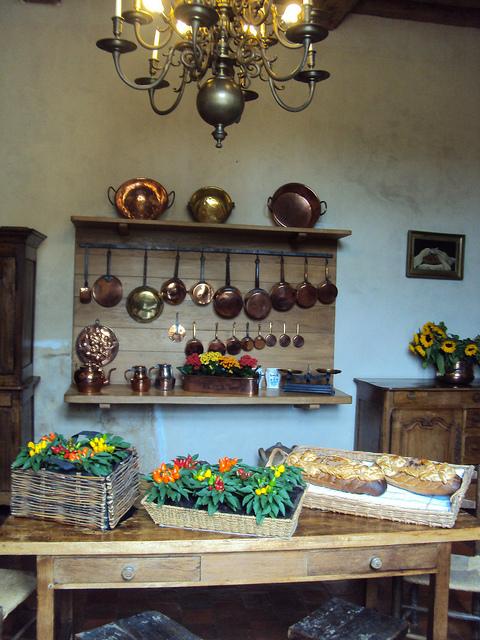Are these flowers real?
Be succinct. Yes. What kind of flowers are in the right hand corner?
Give a very brief answer. Sunflowers. Are there any pots?
Keep it brief. Yes. 